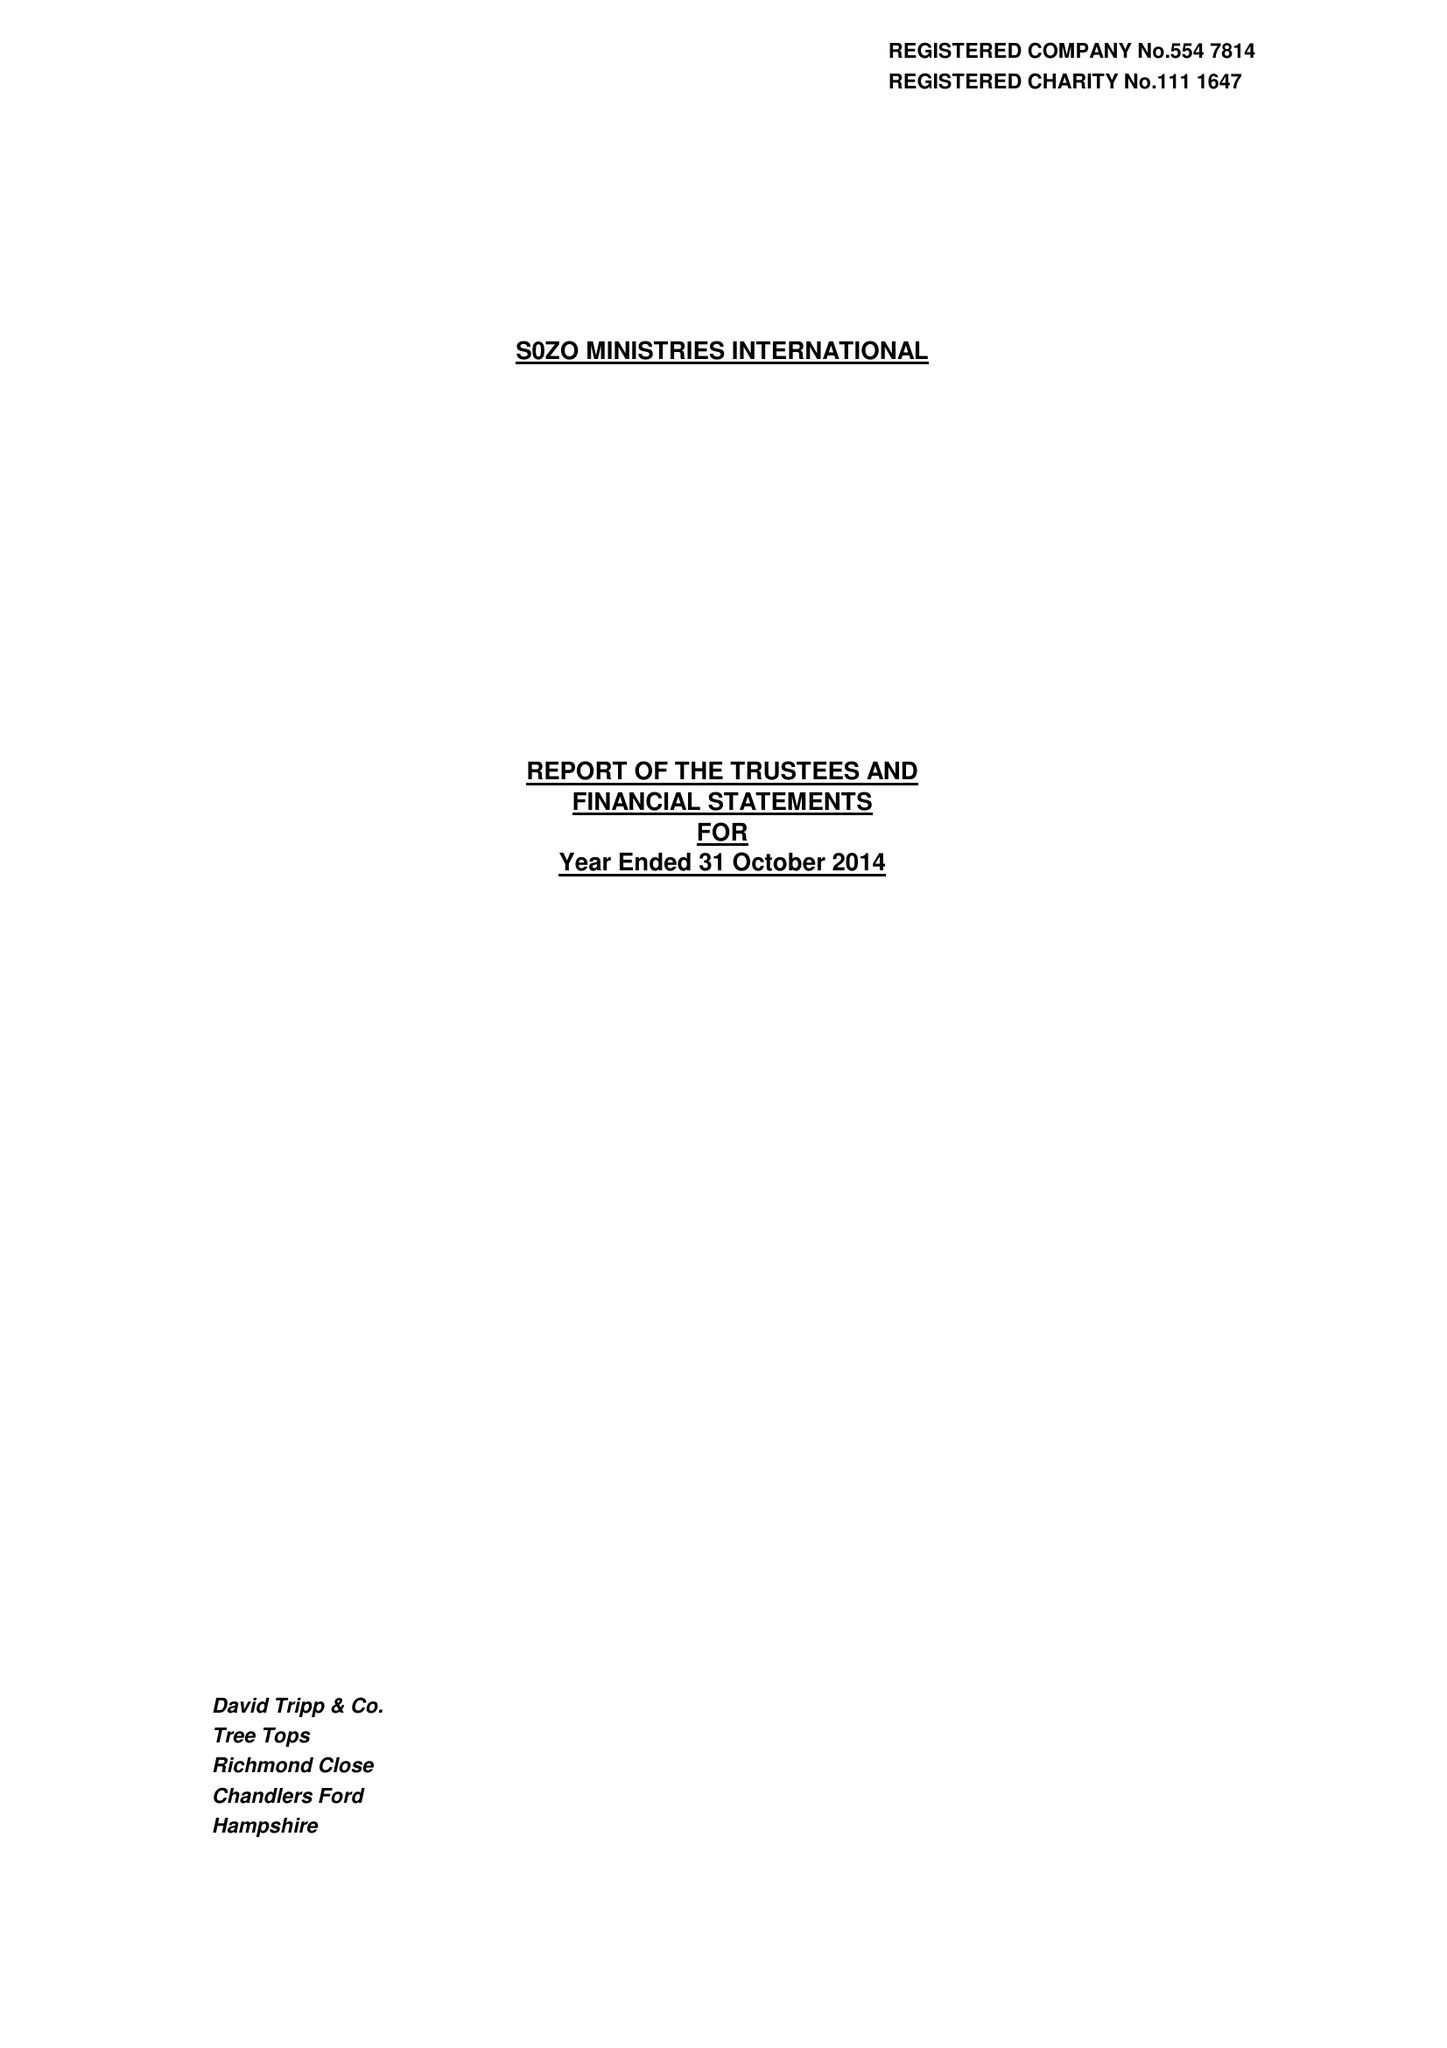What is the value for the report_date?
Answer the question using a single word or phrase. 2014-10-31 